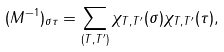<formula> <loc_0><loc_0><loc_500><loc_500>( M ^ { - 1 } ) _ { \sigma \tau } = \sum _ { ( T , T ^ { \prime } ) } \chi _ { T , T ^ { \prime } } ( \sigma ) \chi _ { T , T ^ { \prime } } ( \tau ) ,</formula> 